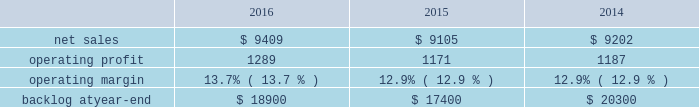Segment includes awe and our share of earnings for our investment in ula , which provides expendable launch services to the u.s .
Government .
Space systems 2019 operating results included the following ( in millions ) : .
2016 compared to 2015 space systems 2019 net sales in 2016 increased $ 304 million , or 3% ( 3 % ) , compared to 2015 .
The increase was attributable to net sales of approximately $ 410 million from awe following the consolidation of this business in the third quarter of 2016 ; and approximately $ 150 million for commercial space transportation programs due to increased launch-related activities ; and approximately $ 70 million of higher net sales for various programs ( primarily fleet ballistic missiles ) due to increased volume .
These increases were partially offset by a decrease in net sales of approximately $ 340 million for government satellite programs due to decreased volume ( primarily sbirs and muos ) and the wind-down or completion of mission solutions programs .
Space systems 2019 operating profit in 2016 increased $ 118 million , or 10% ( 10 % ) , compared to 2015 .
The increase was primarily attributable to a non-cash , pre-tax gain of approximately $ 127 million related to the consolidation of awe ; and approximately $ 80 million of increased equity earnings from joint ventures ( primarily ula ) .
These increases were partially offset by a decrease of approximately $ 105 million for government satellite programs due to lower risk retirements ( primarily sbirs , muos and mission solutions programs ) and decreased volume .
Adjustments not related to volume , including net profit booking rate adjustments , were approximately $ 185 million lower in 2016 compared to 2015 .
2015 compared to 2014 space systems 2019 net sales in 2015 decreased $ 97 million , or 1% ( 1 % ) , compared to 2014 .
The decrease was attributable to approximately $ 335 million lower net sales for government satellite programs due to decreased volume ( primarily aehf ) and the wind-down or completion of mission solutions programs ; and approximately $ 55 million for strategic missile and defense systems due to lower volume .
These decreases were partially offset by higher net sales of approximately $ 235 million for businesses acquired in 2014 ; and approximately $ 75 million for the orion program due to increased volume .
Space systems 2019 operating profit in 2015 decreased $ 16 million , or 1% ( 1 % ) , compared to 2014 .
Operating profit increased approximately $ 85 million for government satellite programs due primarily to increased risk retirements .
This increase was offset by lower operating profit of approximately $ 65 million for commercial satellite programs due to performance matters on certain programs ; and approximately $ 35 million due to decreased equity earnings in joint ventures .
Adjustments not related to volume , including net profit booking rate adjustments and other matters , were approximately $ 105 million higher in 2015 compared to 2014 .
Equity earnings total equity earnings recognized by space systems ( primarily ula ) represented approximately $ 325 million , $ 245 million and $ 280 million , or 25% ( 25 % ) , 21% ( 21 % ) and 24% ( 24 % ) of this business segment 2019s operating profit during 2016 , 2015 and backlog backlog increased in 2016 compared to 2015 primarily due to the addition of awe 2019s backlog .
Backlog decreased in 2015 compared to 2014 primarily due to lower orders for government satellite programs and the orion program and higher sales on the orion program .
Trends we expect space systems 2019 2017 net sales to decrease in the mid-single digit percentage range as compared to 2016 , driven by program lifecycles on government satellite programs , partially offset by the recognition of awe net sales for a full year in 2017 versus a partial year in 2016 following the consolidation of awe in the third quarter of 2016 .
Operating profit .
What were average operating profit for space systems in millions between 2014 and 2016? 
Computations: table_average(operating profit, none)
Answer: 1215.66667. 